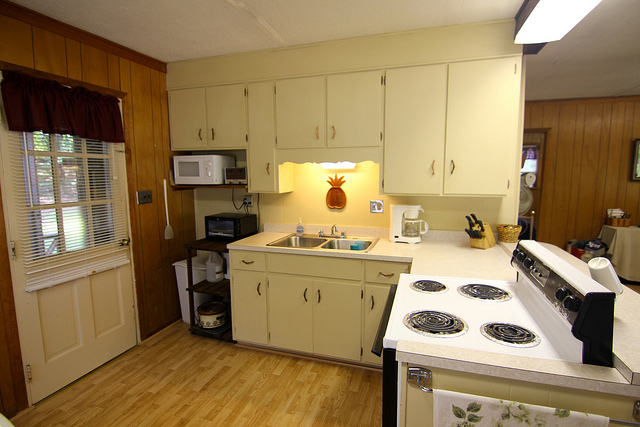<image>Who does the photography? It is ambiguous who does the photography. It could be a photographer, the owner, a man, or any person. Who does the photography? I don't know who does the photography. It can be done by people, man, owner, photographer, person, or real estate agent. 